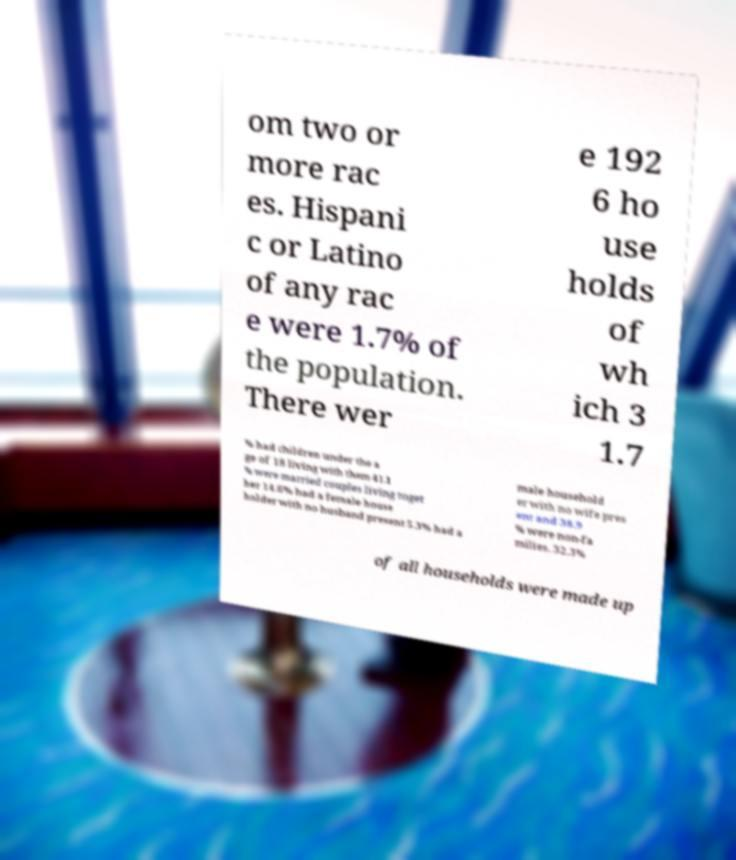Could you assist in decoding the text presented in this image and type it out clearly? om two or more rac es. Hispani c or Latino of any rac e were 1.7% of the population. There wer e 192 6 ho use holds of wh ich 3 1.7 % had children under the a ge of 18 living with them 41.1 % were married couples living toget her 14.6% had a female house holder with no husband present 5.3% had a male household er with no wife pres ent and 38.9 % were non-fa milies. 32.3% of all households were made up 